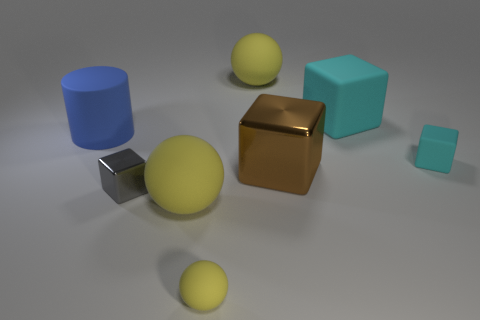What color is the matte object that is on the right side of the tiny yellow sphere and in front of the large cyan matte cube?
Provide a short and direct response. Cyan. How many objects are either yellow things behind the big cyan rubber object or big brown shiny objects?
Your response must be concise. 2. The tiny metallic thing that is the same shape as the large brown object is what color?
Your answer should be very brief. Gray. There is a small yellow object; is it the same shape as the large matte thing in front of the tiny cyan block?
Keep it short and to the point. Yes. How many things are large rubber objects that are in front of the big cyan object or large yellow rubber spheres that are behind the large blue rubber thing?
Make the answer very short. 3. Is the number of gray metal objects behind the tiny yellow matte object less than the number of tiny cyan rubber objects?
Keep it short and to the point. No. Do the brown cube and the large sphere in front of the big metal object have the same material?
Your response must be concise. No. What is the tiny cyan object made of?
Ensure brevity in your answer.  Rubber. What material is the yellow object that is behind the large yellow thing in front of the large block in front of the large cyan rubber thing made of?
Give a very brief answer. Rubber. There is a tiny sphere; is its color the same as the matte cube that is behind the tiny cyan object?
Your answer should be compact. No. 